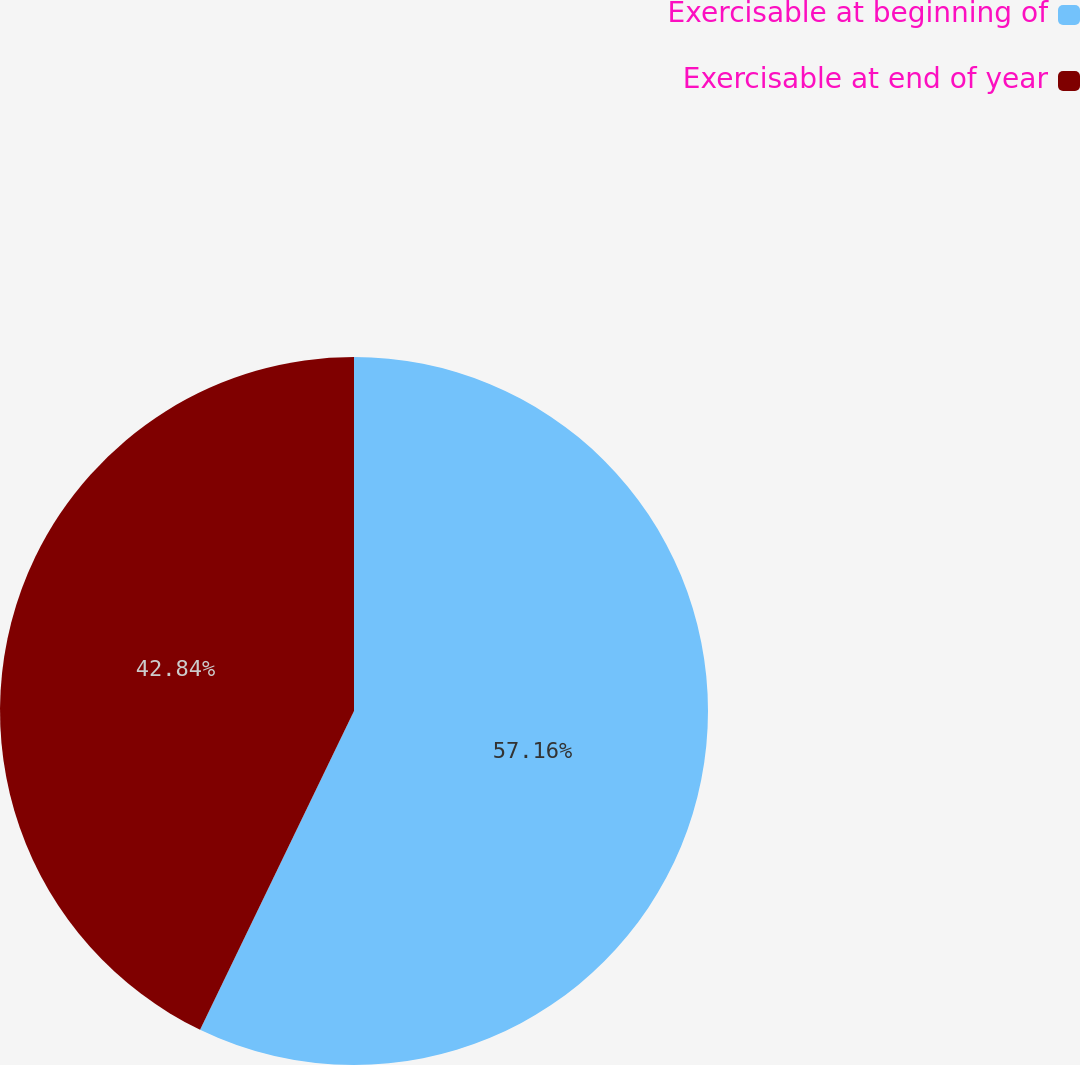<chart> <loc_0><loc_0><loc_500><loc_500><pie_chart><fcel>Exercisable at beginning of<fcel>Exercisable at end of year<nl><fcel>57.16%<fcel>42.84%<nl></chart> 